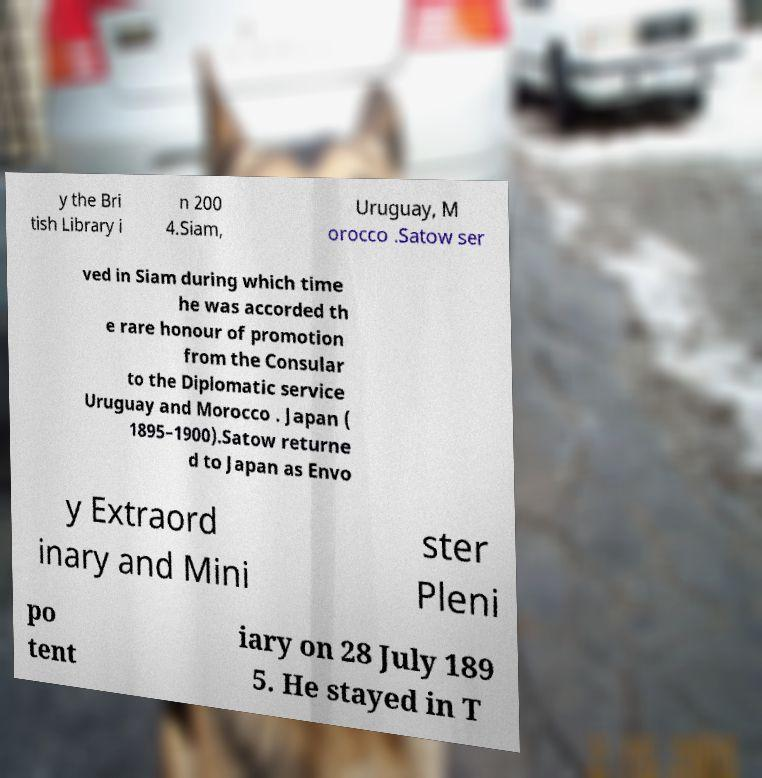Please read and relay the text visible in this image. What does it say? y the Bri tish Library i n 200 4.Siam, Uruguay, M orocco .Satow ser ved in Siam during which time he was accorded th e rare honour of promotion from the Consular to the Diplomatic service Uruguay and Morocco . Japan ( 1895–1900).Satow returne d to Japan as Envo y Extraord inary and Mini ster Pleni po tent iary on 28 July 189 5. He stayed in T 